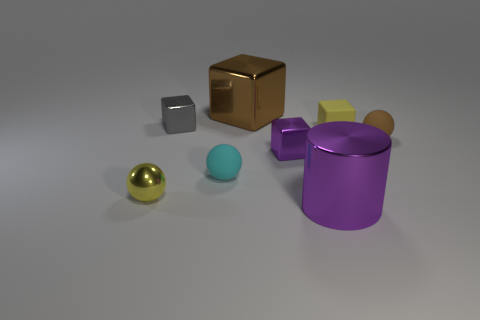How many gray rubber objects are the same shape as the yellow rubber object? In the image provided, there are no gray rubber objects that share the same shape as the yellow rubber object, which appears to be a cube. 